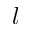<formula> <loc_0><loc_0><loc_500><loc_500>l</formula> 